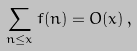Convert formula to latex. <formula><loc_0><loc_0><loc_500><loc_500>\sum _ { n \leq x } f ( n ) = O ( x ) \, ,</formula> 